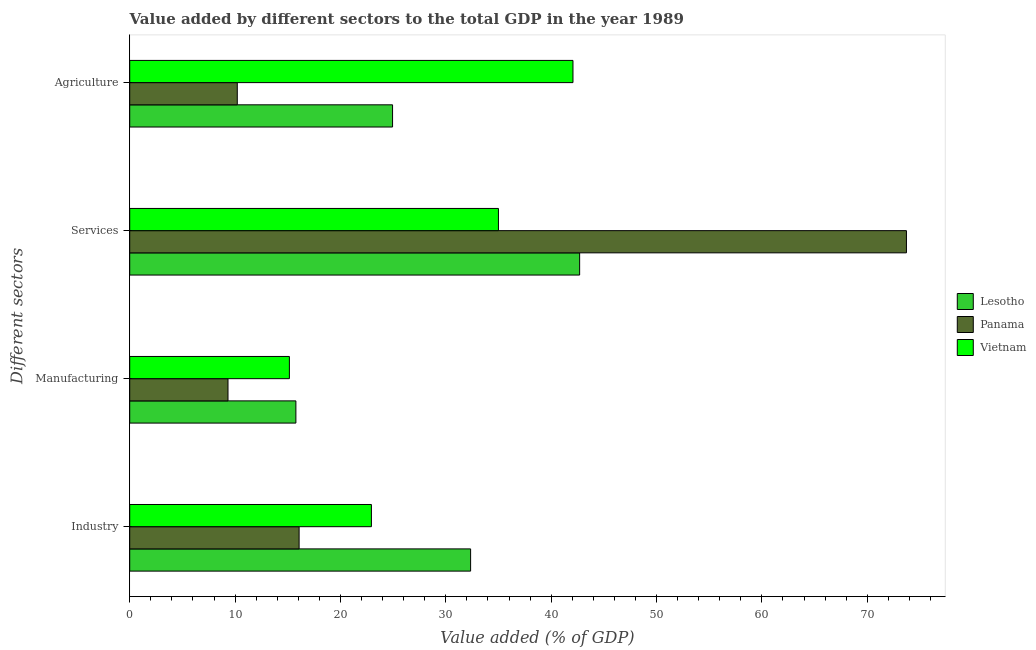How many different coloured bars are there?
Provide a short and direct response. 3. Are the number of bars on each tick of the Y-axis equal?
Keep it short and to the point. Yes. How many bars are there on the 3rd tick from the bottom?
Offer a very short reply. 3. What is the label of the 1st group of bars from the top?
Provide a succinct answer. Agriculture. What is the value added by industrial sector in Panama?
Your answer should be very brief. 16.08. Across all countries, what is the maximum value added by services sector?
Offer a very short reply. 73.72. Across all countries, what is the minimum value added by industrial sector?
Offer a terse response. 16.08. In which country was the value added by manufacturing sector maximum?
Offer a very short reply. Lesotho. In which country was the value added by industrial sector minimum?
Offer a very short reply. Panama. What is the total value added by manufacturing sector in the graph?
Ensure brevity in your answer.  40.25. What is the difference between the value added by services sector in Lesotho and that in Panama?
Offer a very short reply. -31.02. What is the difference between the value added by manufacturing sector in Vietnam and the value added by industrial sector in Lesotho?
Make the answer very short. -17.2. What is the average value added by manufacturing sector per country?
Keep it short and to the point. 13.42. What is the difference between the value added by industrial sector and value added by services sector in Panama?
Provide a succinct answer. -57.64. In how many countries, is the value added by manufacturing sector greater than 52 %?
Give a very brief answer. 0. What is the ratio of the value added by agricultural sector in Lesotho to that in Panama?
Make the answer very short. 2.44. Is the value added by services sector in Lesotho less than that in Vietnam?
Keep it short and to the point. No. What is the difference between the highest and the second highest value added by agricultural sector?
Offer a very short reply. 17.12. What is the difference between the highest and the lowest value added by manufacturing sector?
Your answer should be very brief. 6.44. Is the sum of the value added by agricultural sector in Lesotho and Vietnam greater than the maximum value added by industrial sector across all countries?
Provide a short and direct response. Yes. Is it the case that in every country, the sum of the value added by agricultural sector and value added by services sector is greater than the sum of value added by industrial sector and value added by manufacturing sector?
Your answer should be very brief. Yes. What does the 2nd bar from the top in Industry represents?
Offer a terse response. Panama. What does the 1st bar from the bottom in Services represents?
Ensure brevity in your answer.  Lesotho. Is it the case that in every country, the sum of the value added by industrial sector and value added by manufacturing sector is greater than the value added by services sector?
Offer a terse response. No. How many bars are there?
Keep it short and to the point. 12. Are all the bars in the graph horizontal?
Provide a short and direct response. Yes. How many countries are there in the graph?
Your answer should be compact. 3. Where does the legend appear in the graph?
Offer a very short reply. Center right. How many legend labels are there?
Provide a short and direct response. 3. How are the legend labels stacked?
Provide a succinct answer. Vertical. What is the title of the graph?
Your answer should be very brief. Value added by different sectors to the total GDP in the year 1989. Does "Europe(developing only)" appear as one of the legend labels in the graph?
Offer a terse response. No. What is the label or title of the X-axis?
Your answer should be very brief. Value added (% of GDP). What is the label or title of the Y-axis?
Keep it short and to the point. Different sectors. What is the Value added (% of GDP) of Lesotho in Industry?
Provide a succinct answer. 32.35. What is the Value added (% of GDP) in Panama in Industry?
Ensure brevity in your answer.  16.08. What is the Value added (% of GDP) of Vietnam in Industry?
Make the answer very short. 22.94. What is the Value added (% of GDP) of Lesotho in Manufacturing?
Give a very brief answer. 15.77. What is the Value added (% of GDP) in Panama in Manufacturing?
Ensure brevity in your answer.  9.33. What is the Value added (% of GDP) in Vietnam in Manufacturing?
Make the answer very short. 15.15. What is the Value added (% of GDP) of Lesotho in Services?
Offer a terse response. 42.7. What is the Value added (% of GDP) in Panama in Services?
Provide a succinct answer. 73.72. What is the Value added (% of GDP) of Vietnam in Services?
Provide a succinct answer. 34.99. What is the Value added (% of GDP) of Lesotho in Agriculture?
Keep it short and to the point. 24.95. What is the Value added (% of GDP) in Panama in Agriculture?
Offer a terse response. 10.21. What is the Value added (% of GDP) in Vietnam in Agriculture?
Your answer should be compact. 42.07. Across all Different sectors, what is the maximum Value added (% of GDP) of Lesotho?
Offer a very short reply. 42.7. Across all Different sectors, what is the maximum Value added (% of GDP) of Panama?
Offer a terse response. 73.72. Across all Different sectors, what is the maximum Value added (% of GDP) in Vietnam?
Provide a short and direct response. 42.07. Across all Different sectors, what is the minimum Value added (% of GDP) in Lesotho?
Provide a succinct answer. 15.77. Across all Different sectors, what is the minimum Value added (% of GDP) of Panama?
Give a very brief answer. 9.33. Across all Different sectors, what is the minimum Value added (% of GDP) in Vietnam?
Offer a terse response. 15.15. What is the total Value added (% of GDP) in Lesotho in the graph?
Your answer should be compact. 115.77. What is the total Value added (% of GDP) in Panama in the graph?
Your response must be concise. 109.33. What is the total Value added (% of GDP) of Vietnam in the graph?
Offer a terse response. 115.15. What is the difference between the Value added (% of GDP) of Lesotho in Industry and that in Manufacturing?
Offer a very short reply. 16.58. What is the difference between the Value added (% of GDP) in Panama in Industry and that in Manufacturing?
Keep it short and to the point. 6.75. What is the difference between the Value added (% of GDP) of Vietnam in Industry and that in Manufacturing?
Provide a short and direct response. 7.78. What is the difference between the Value added (% of GDP) of Lesotho in Industry and that in Services?
Your answer should be compact. -10.35. What is the difference between the Value added (% of GDP) of Panama in Industry and that in Services?
Give a very brief answer. -57.64. What is the difference between the Value added (% of GDP) in Vietnam in Industry and that in Services?
Your answer should be very brief. -12.06. What is the difference between the Value added (% of GDP) in Lesotho in Industry and that in Agriculture?
Provide a succinct answer. 7.41. What is the difference between the Value added (% of GDP) in Panama in Industry and that in Agriculture?
Give a very brief answer. 5.87. What is the difference between the Value added (% of GDP) of Vietnam in Industry and that in Agriculture?
Keep it short and to the point. -19.13. What is the difference between the Value added (% of GDP) in Lesotho in Manufacturing and that in Services?
Provide a short and direct response. -26.93. What is the difference between the Value added (% of GDP) of Panama in Manufacturing and that in Services?
Offer a terse response. -64.39. What is the difference between the Value added (% of GDP) of Vietnam in Manufacturing and that in Services?
Your answer should be compact. -19.84. What is the difference between the Value added (% of GDP) in Lesotho in Manufacturing and that in Agriculture?
Your response must be concise. -9.18. What is the difference between the Value added (% of GDP) of Panama in Manufacturing and that in Agriculture?
Make the answer very short. -0.88. What is the difference between the Value added (% of GDP) in Vietnam in Manufacturing and that in Agriculture?
Offer a terse response. -26.91. What is the difference between the Value added (% of GDP) of Lesotho in Services and that in Agriculture?
Offer a terse response. 17.76. What is the difference between the Value added (% of GDP) of Panama in Services and that in Agriculture?
Provide a short and direct response. 63.51. What is the difference between the Value added (% of GDP) in Vietnam in Services and that in Agriculture?
Your response must be concise. -7.07. What is the difference between the Value added (% of GDP) in Lesotho in Industry and the Value added (% of GDP) in Panama in Manufacturing?
Offer a terse response. 23.03. What is the difference between the Value added (% of GDP) in Lesotho in Industry and the Value added (% of GDP) in Vietnam in Manufacturing?
Offer a very short reply. 17.2. What is the difference between the Value added (% of GDP) of Panama in Industry and the Value added (% of GDP) of Vietnam in Manufacturing?
Keep it short and to the point. 0.92. What is the difference between the Value added (% of GDP) in Lesotho in Industry and the Value added (% of GDP) in Panama in Services?
Your answer should be compact. -41.36. What is the difference between the Value added (% of GDP) of Lesotho in Industry and the Value added (% of GDP) of Vietnam in Services?
Ensure brevity in your answer.  -2.64. What is the difference between the Value added (% of GDP) of Panama in Industry and the Value added (% of GDP) of Vietnam in Services?
Provide a short and direct response. -18.92. What is the difference between the Value added (% of GDP) in Lesotho in Industry and the Value added (% of GDP) in Panama in Agriculture?
Offer a terse response. 22.15. What is the difference between the Value added (% of GDP) of Lesotho in Industry and the Value added (% of GDP) of Vietnam in Agriculture?
Offer a terse response. -9.71. What is the difference between the Value added (% of GDP) in Panama in Industry and the Value added (% of GDP) in Vietnam in Agriculture?
Your answer should be compact. -25.99. What is the difference between the Value added (% of GDP) of Lesotho in Manufacturing and the Value added (% of GDP) of Panama in Services?
Offer a very short reply. -57.95. What is the difference between the Value added (% of GDP) in Lesotho in Manufacturing and the Value added (% of GDP) in Vietnam in Services?
Provide a short and direct response. -19.22. What is the difference between the Value added (% of GDP) of Panama in Manufacturing and the Value added (% of GDP) of Vietnam in Services?
Make the answer very short. -25.67. What is the difference between the Value added (% of GDP) in Lesotho in Manufacturing and the Value added (% of GDP) in Panama in Agriculture?
Give a very brief answer. 5.56. What is the difference between the Value added (% of GDP) of Lesotho in Manufacturing and the Value added (% of GDP) of Vietnam in Agriculture?
Your answer should be compact. -26.3. What is the difference between the Value added (% of GDP) of Panama in Manufacturing and the Value added (% of GDP) of Vietnam in Agriculture?
Your answer should be very brief. -32.74. What is the difference between the Value added (% of GDP) of Lesotho in Services and the Value added (% of GDP) of Panama in Agriculture?
Your answer should be compact. 32.49. What is the difference between the Value added (% of GDP) in Lesotho in Services and the Value added (% of GDP) in Vietnam in Agriculture?
Keep it short and to the point. 0.63. What is the difference between the Value added (% of GDP) in Panama in Services and the Value added (% of GDP) in Vietnam in Agriculture?
Your response must be concise. 31.65. What is the average Value added (% of GDP) in Lesotho per Different sectors?
Provide a short and direct response. 28.94. What is the average Value added (% of GDP) in Panama per Different sectors?
Provide a succinct answer. 27.33. What is the average Value added (% of GDP) of Vietnam per Different sectors?
Your answer should be compact. 28.79. What is the difference between the Value added (% of GDP) of Lesotho and Value added (% of GDP) of Panama in Industry?
Provide a succinct answer. 16.28. What is the difference between the Value added (% of GDP) of Lesotho and Value added (% of GDP) of Vietnam in Industry?
Ensure brevity in your answer.  9.42. What is the difference between the Value added (% of GDP) in Panama and Value added (% of GDP) in Vietnam in Industry?
Your response must be concise. -6.86. What is the difference between the Value added (% of GDP) in Lesotho and Value added (% of GDP) in Panama in Manufacturing?
Your response must be concise. 6.44. What is the difference between the Value added (% of GDP) of Lesotho and Value added (% of GDP) of Vietnam in Manufacturing?
Offer a very short reply. 0.62. What is the difference between the Value added (% of GDP) in Panama and Value added (% of GDP) in Vietnam in Manufacturing?
Offer a very short reply. -5.83. What is the difference between the Value added (% of GDP) of Lesotho and Value added (% of GDP) of Panama in Services?
Give a very brief answer. -31.02. What is the difference between the Value added (% of GDP) in Lesotho and Value added (% of GDP) in Vietnam in Services?
Ensure brevity in your answer.  7.71. What is the difference between the Value added (% of GDP) in Panama and Value added (% of GDP) in Vietnam in Services?
Offer a terse response. 38.72. What is the difference between the Value added (% of GDP) of Lesotho and Value added (% of GDP) of Panama in Agriculture?
Offer a very short reply. 14.74. What is the difference between the Value added (% of GDP) of Lesotho and Value added (% of GDP) of Vietnam in Agriculture?
Provide a succinct answer. -17.12. What is the difference between the Value added (% of GDP) in Panama and Value added (% of GDP) in Vietnam in Agriculture?
Offer a terse response. -31.86. What is the ratio of the Value added (% of GDP) in Lesotho in Industry to that in Manufacturing?
Give a very brief answer. 2.05. What is the ratio of the Value added (% of GDP) of Panama in Industry to that in Manufacturing?
Offer a terse response. 1.72. What is the ratio of the Value added (% of GDP) of Vietnam in Industry to that in Manufacturing?
Provide a short and direct response. 1.51. What is the ratio of the Value added (% of GDP) of Lesotho in Industry to that in Services?
Your answer should be very brief. 0.76. What is the ratio of the Value added (% of GDP) in Panama in Industry to that in Services?
Your response must be concise. 0.22. What is the ratio of the Value added (% of GDP) of Vietnam in Industry to that in Services?
Provide a succinct answer. 0.66. What is the ratio of the Value added (% of GDP) in Lesotho in Industry to that in Agriculture?
Provide a short and direct response. 1.3. What is the ratio of the Value added (% of GDP) in Panama in Industry to that in Agriculture?
Offer a very short reply. 1.57. What is the ratio of the Value added (% of GDP) in Vietnam in Industry to that in Agriculture?
Your answer should be very brief. 0.55. What is the ratio of the Value added (% of GDP) in Lesotho in Manufacturing to that in Services?
Provide a short and direct response. 0.37. What is the ratio of the Value added (% of GDP) of Panama in Manufacturing to that in Services?
Give a very brief answer. 0.13. What is the ratio of the Value added (% of GDP) of Vietnam in Manufacturing to that in Services?
Offer a very short reply. 0.43. What is the ratio of the Value added (% of GDP) in Lesotho in Manufacturing to that in Agriculture?
Provide a succinct answer. 0.63. What is the ratio of the Value added (% of GDP) in Panama in Manufacturing to that in Agriculture?
Offer a terse response. 0.91. What is the ratio of the Value added (% of GDP) in Vietnam in Manufacturing to that in Agriculture?
Offer a very short reply. 0.36. What is the ratio of the Value added (% of GDP) of Lesotho in Services to that in Agriculture?
Provide a succinct answer. 1.71. What is the ratio of the Value added (% of GDP) of Panama in Services to that in Agriculture?
Provide a short and direct response. 7.22. What is the ratio of the Value added (% of GDP) of Vietnam in Services to that in Agriculture?
Keep it short and to the point. 0.83. What is the difference between the highest and the second highest Value added (% of GDP) of Lesotho?
Keep it short and to the point. 10.35. What is the difference between the highest and the second highest Value added (% of GDP) in Panama?
Your answer should be very brief. 57.64. What is the difference between the highest and the second highest Value added (% of GDP) in Vietnam?
Your answer should be compact. 7.07. What is the difference between the highest and the lowest Value added (% of GDP) of Lesotho?
Provide a short and direct response. 26.93. What is the difference between the highest and the lowest Value added (% of GDP) in Panama?
Ensure brevity in your answer.  64.39. What is the difference between the highest and the lowest Value added (% of GDP) of Vietnam?
Your answer should be compact. 26.91. 